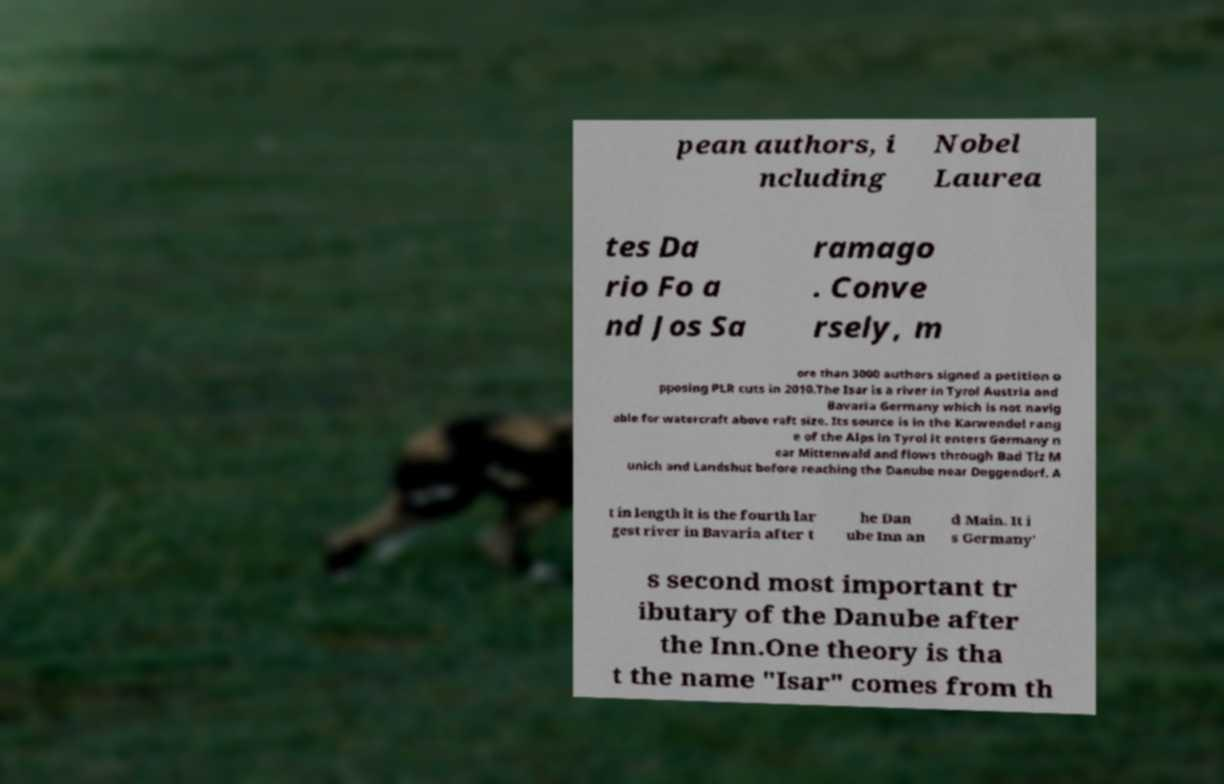Can you accurately transcribe the text from the provided image for me? pean authors, i ncluding Nobel Laurea tes Da rio Fo a nd Jos Sa ramago . Conve rsely, m ore than 3000 authors signed a petition o pposing PLR cuts in 2010.The Isar is a river in Tyrol Austria and Bavaria Germany which is not navig able for watercraft above raft size. Its source is in the Karwendel rang e of the Alps in Tyrol it enters Germany n ear Mittenwald and flows through Bad Tlz M unich and Landshut before reaching the Danube near Deggendorf. A t in length it is the fourth lar gest river in Bavaria after t he Dan ube Inn an d Main. It i s Germany' s second most important tr ibutary of the Danube after the Inn.One theory is tha t the name "Isar" comes from th 